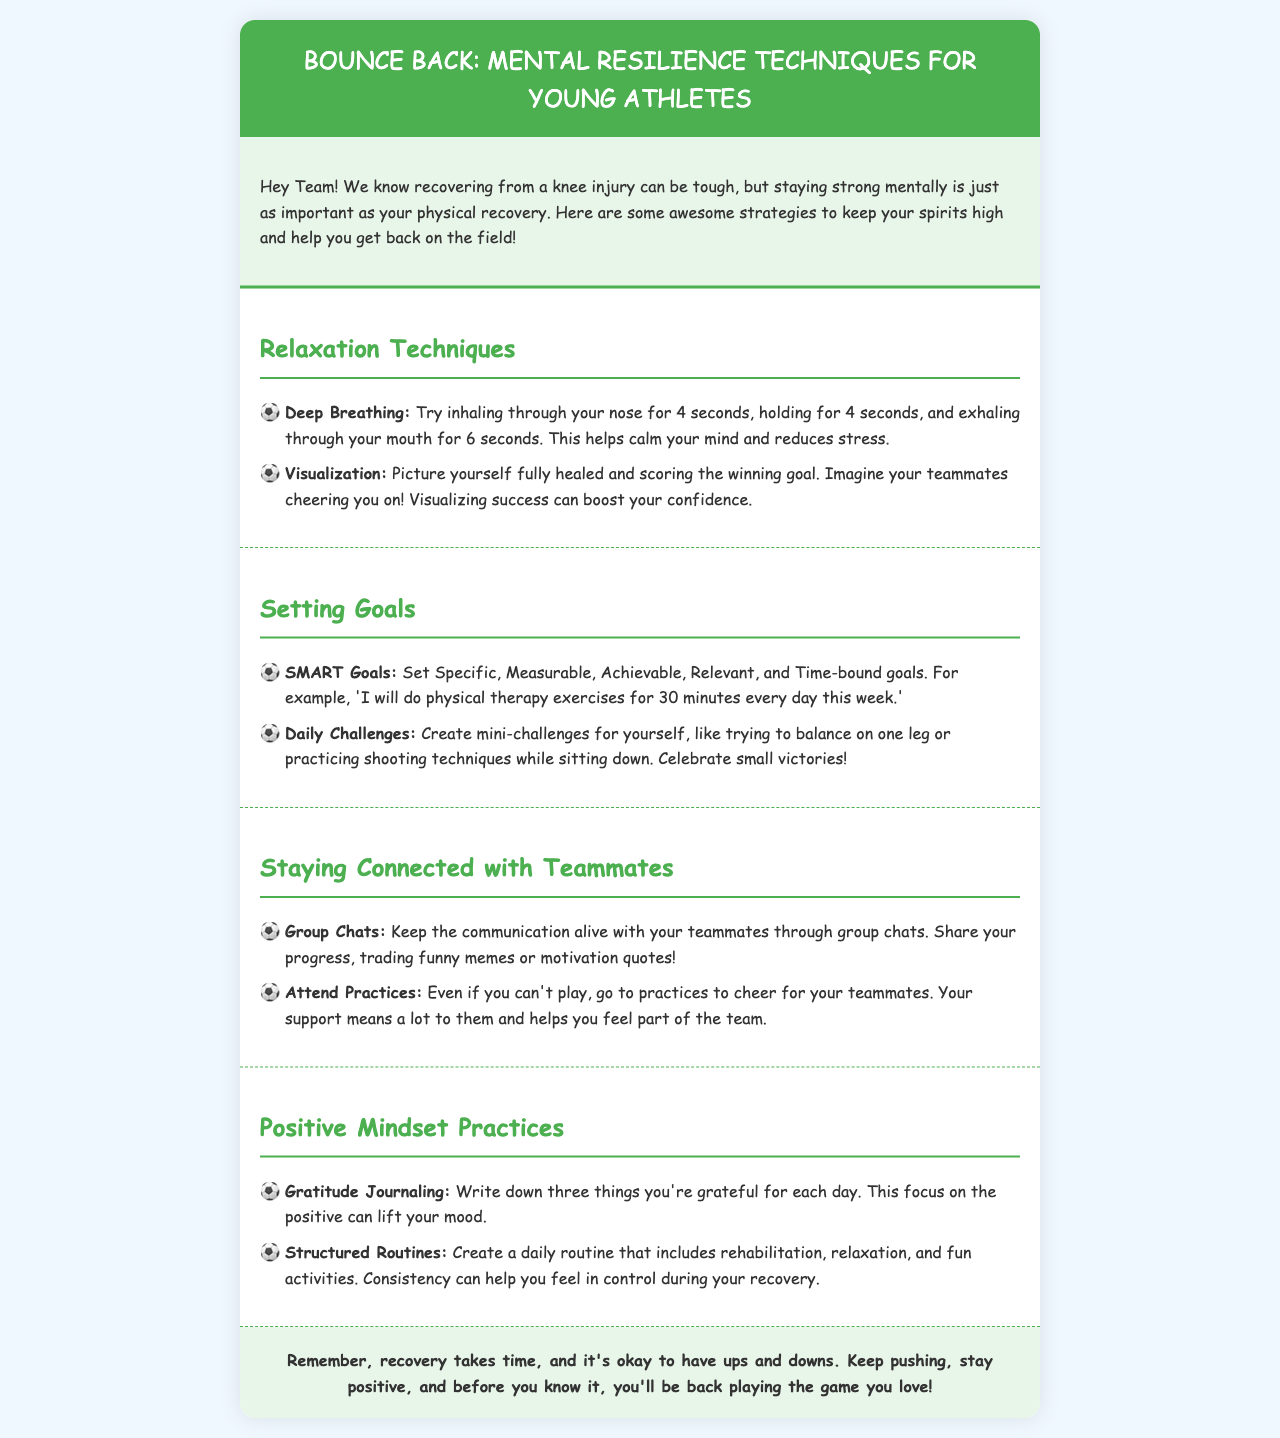What are two relaxation techniques mentioned? The document lists deep breathing and visualization as relaxation techniques.
Answer: Deep breathing, visualization What does SMART stand for in goal-setting? SMART stands for Specific, Measurable, Achievable, Relevant, and Time-bound.
Answer: Specific, Measurable, Achievable, Relevant, Time-bound What is a suggested daily challenge for recovery? The document suggests creating mini-challenges, such as balancing on one leg or practicing shooting techniques while sitting down.
Answer: Balancing on one leg Which practice helps improve your mood? Gratitude journaling is mentioned as a practice that can lift your mood by focusing on positives.
Answer: Gratitude journaling How often should you write in a gratitude journal? The document recommends writing three things every day.
Answer: Each day 